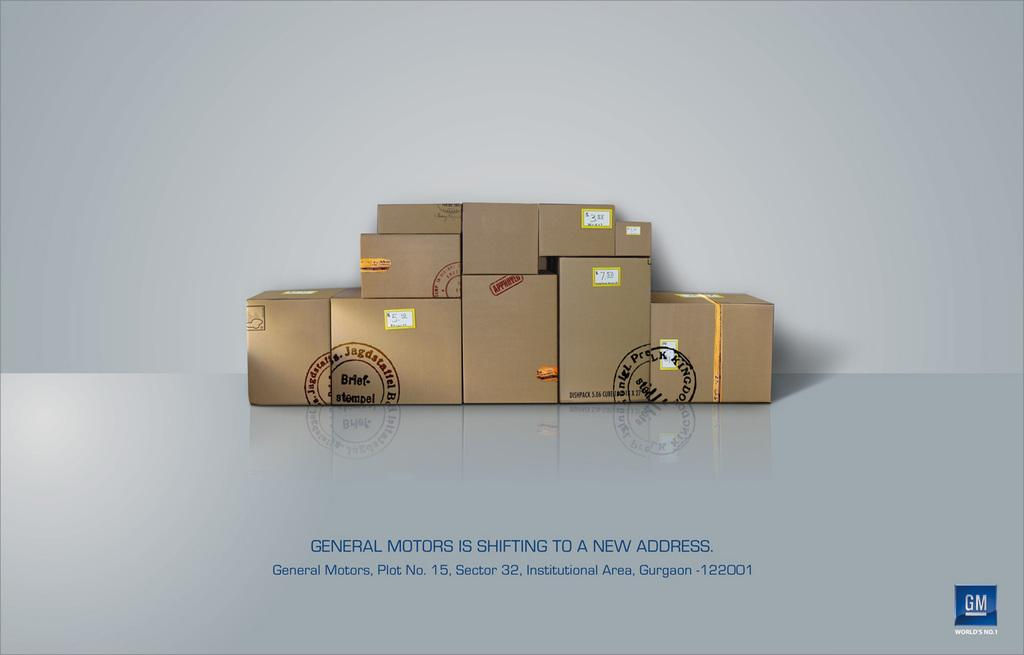<image>
Present a compact description of the photo's key features. A group of brown packages with the message General Motors is Shifting to a New Address. 